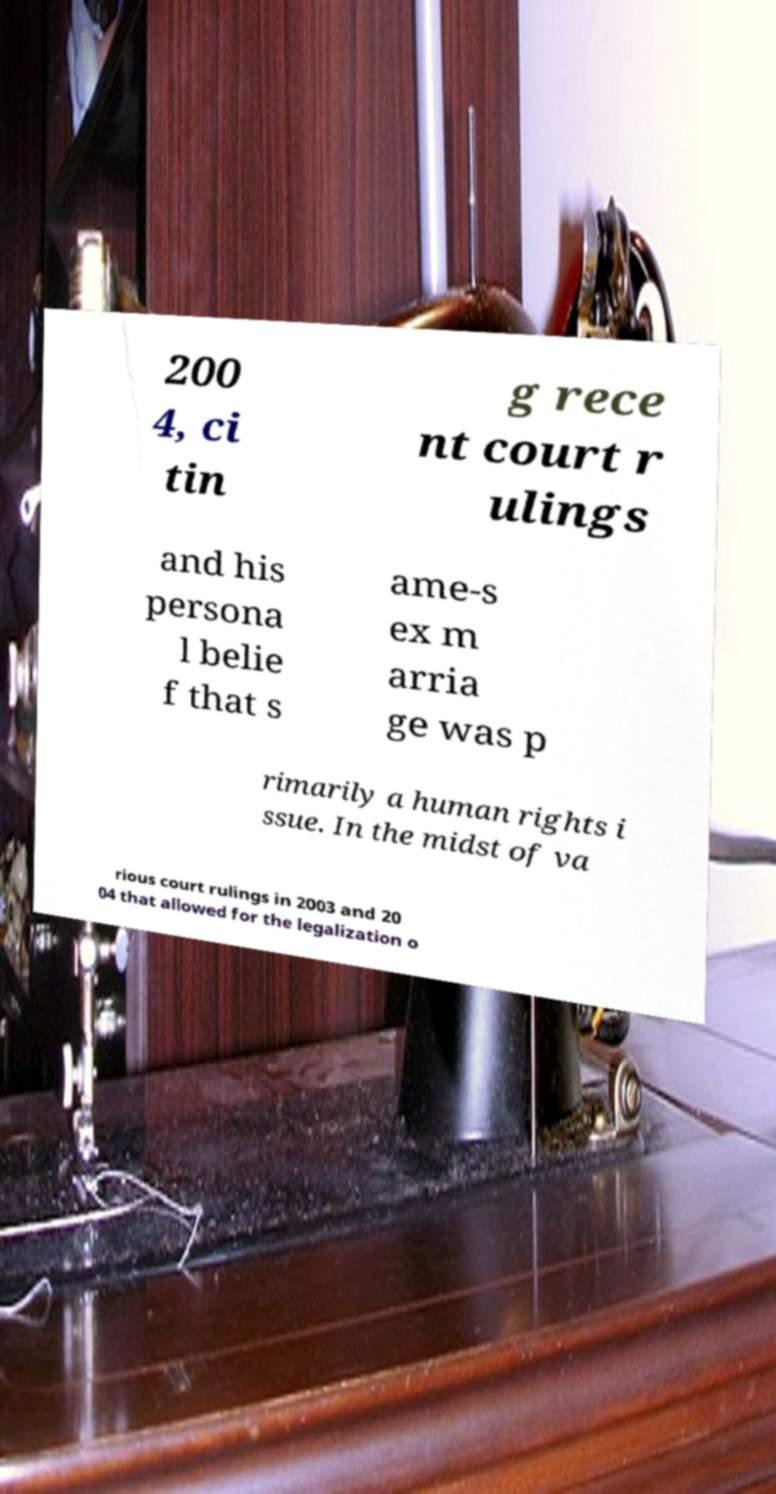I need the written content from this picture converted into text. Can you do that? 200 4, ci tin g rece nt court r ulings and his persona l belie f that s ame-s ex m arria ge was p rimarily a human rights i ssue. In the midst of va rious court rulings in 2003 and 20 04 that allowed for the legalization o 